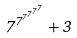<formula> <loc_0><loc_0><loc_500><loc_500>7 ^ { 7 ^ { 7 ^ { 7 ^ { 7 ^ { 7 } } } } } + 3</formula> 